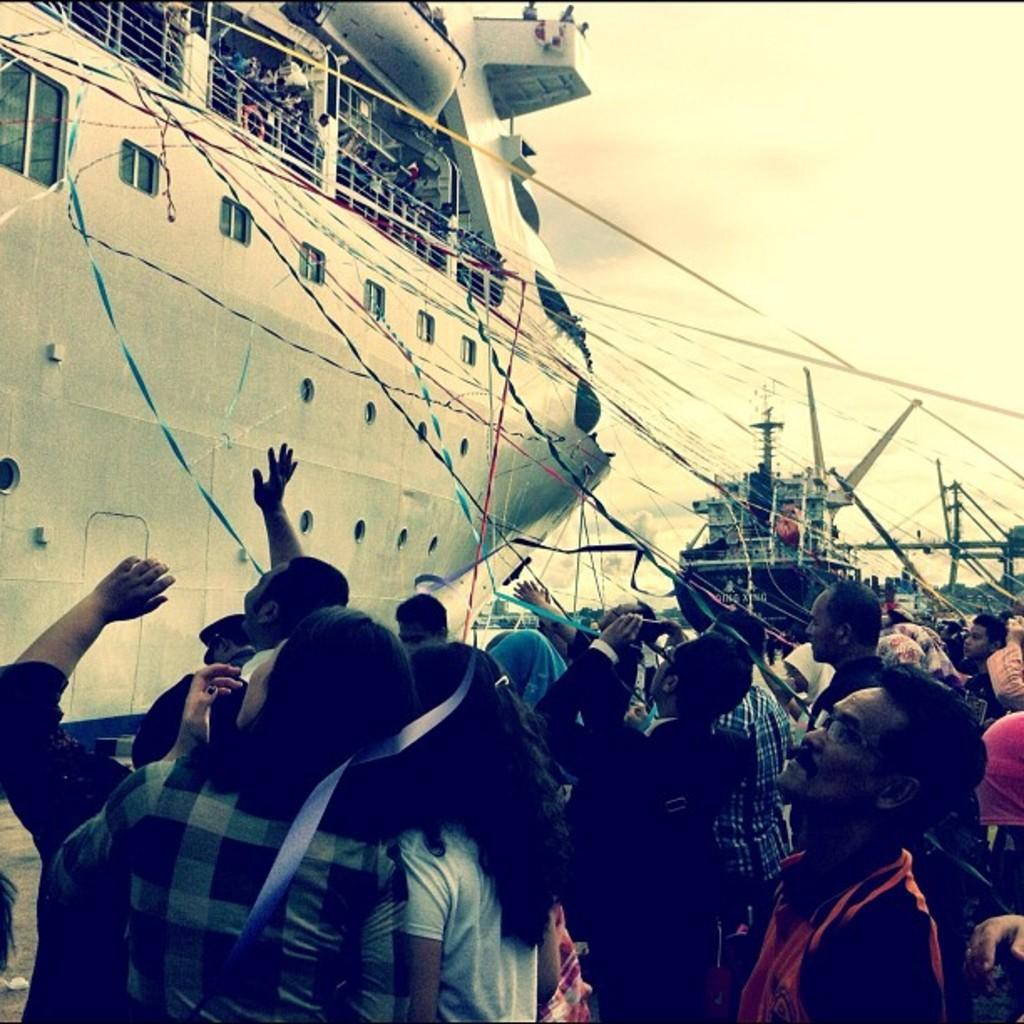Please provide a concise description of this image. On the right side a group of people are standing and looking at the ship in the left side of an image. 